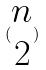Convert formula to latex. <formula><loc_0><loc_0><loc_500><loc_500>( \begin{matrix} n \\ 2 \end{matrix} )</formula> 